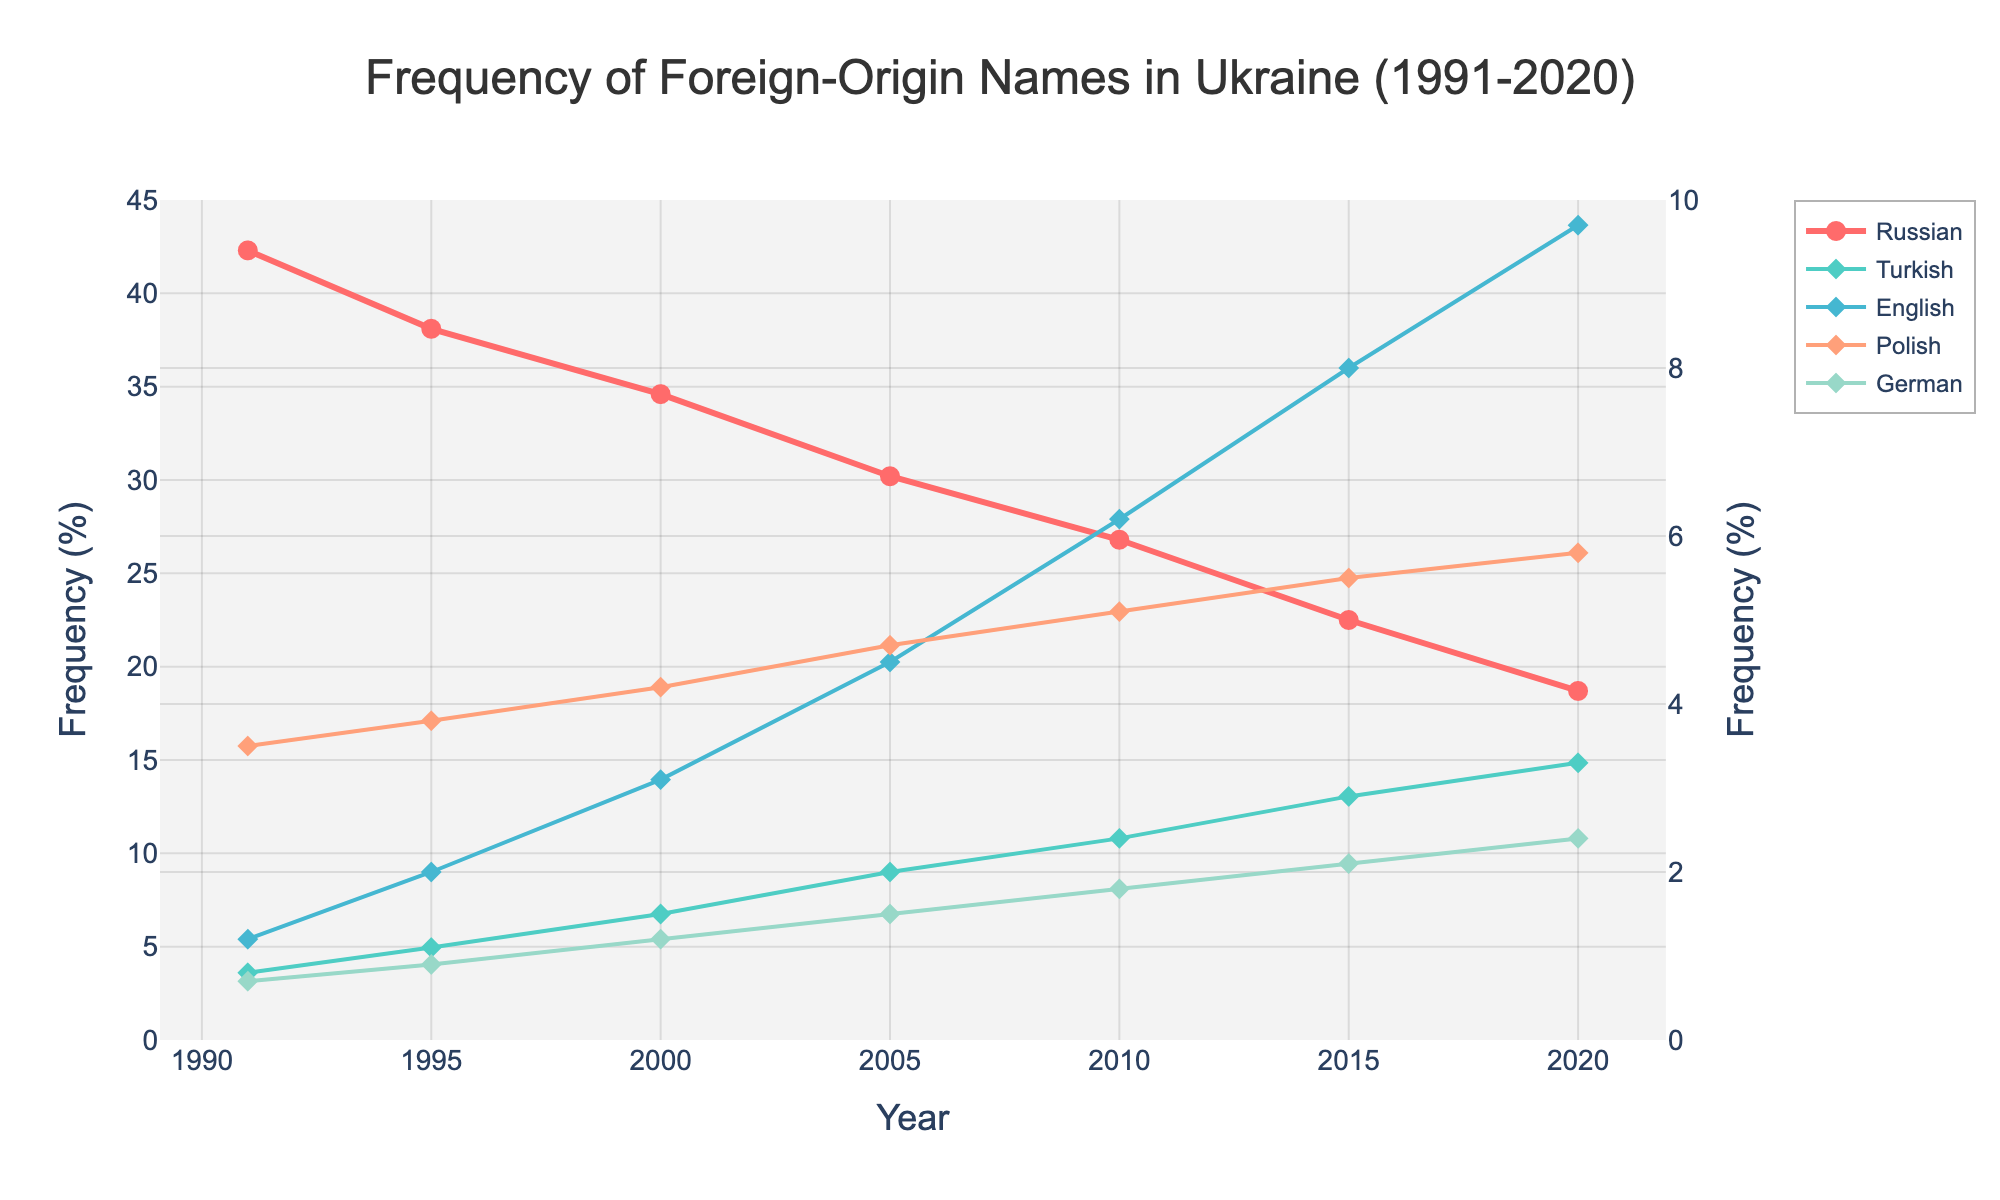What is the general trend for Russian-origin names from 1991 to 2020? The visual plot shows a solid line with markers that declines steadily over the years for Russian-origin names. Specifically, the frequency decreases from 42.3% in 1991 to 18.7% in 2020.
Answer: The frequency decreases How does the frequency of English-origin names in 2020 compare to that in 1991? Look at the data points for English-origin names. In 1991, the frequency is 1.2%, while in 2020, it increases to 9.7%. This shows a significant rise.
Answer: It increases Which foreign-origin name has the highest frequency in 2005 apart from Russian? By observing the secondary y-axis and the lines, English-origin names have the highest percentage among non-Russian names, with a frequency of 4.5% in 2005.
Answer: English What is the difference in frequency of Turkish-origin names between 1995 and 2010? The frequency of Turkish-origin names in 1995 is 1.1%, and in 2010 it is 2.4%. The difference is calculated as 2.4% - 1.1% = 1.3%.
Answer: 1.3% Which year shows the smallest gap between Russian-origin names and Polish-origin names? The gap appears smallest in 2020. The frequency of Russian-origin names is 18.7%, while Polish-origin names are 5.8%. The gap is 18.7% - 5.8% = 12.9%. Note that this is the smallest difference when compared across the years.
Answer: 2020 What is the combined frequency of Turkish- and German-origin names in 2015? Look at the frequencies for Turkish-origin names (2.9%) and German-origin names (2.1%) in 2015. Adding these gives 2.9% + 2.1% = 5.0%.
Answer: 5.0% Which foreign-origin name has shown the most growth from 1991 to 2020? By comparing the starting and ending points for all non-Russian-origin names, English-origin names show the most significant increase from 1.2% in 1991 to 9.7% in 2020, which is an 8.5% rise.
Answer: English What is the average frequency of Polish-origin names over the three decades provided? Sum the frequencies of Polish-origin names across the years (3.5%, 3.8%, 4.2%, 4.7%, 5.1%, 5.5%, 5.8%) and divide by 7 years. (3.5 + 3.8 + 4.2 + 4.7 + 5.1 + 5.5 + 5.8) / 7 = 4.66%.
Answer: 4.66% How many countries' names are plotted on the secondary y-axis? The plot shows countries' names on primary and secondary y-axes with Russian being on the primary. Turkish, English, Polish, and German are plotted on the secondary y-axis, totaling four.
Answer: Four 